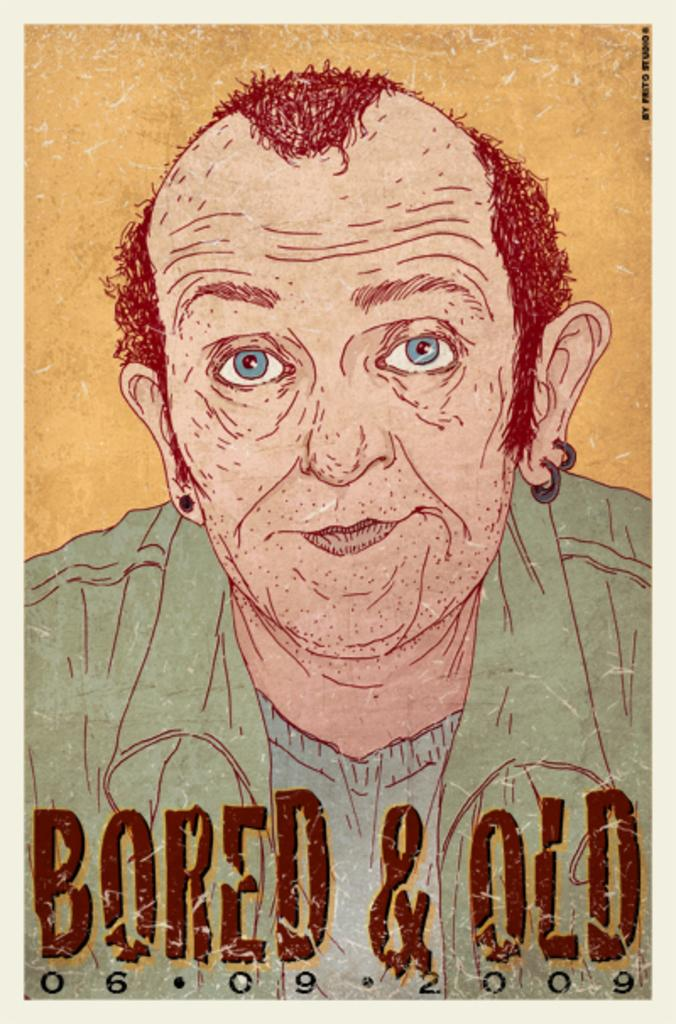<image>
Give a short and clear explanation of the subsequent image. Cartoon drawing of a man with earrings and the words "Bored & Old" below him. 